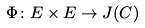Convert formula to latex. <formula><loc_0><loc_0><loc_500><loc_500>\Phi \colon E \times E \rightarrow J ( C )</formula> 